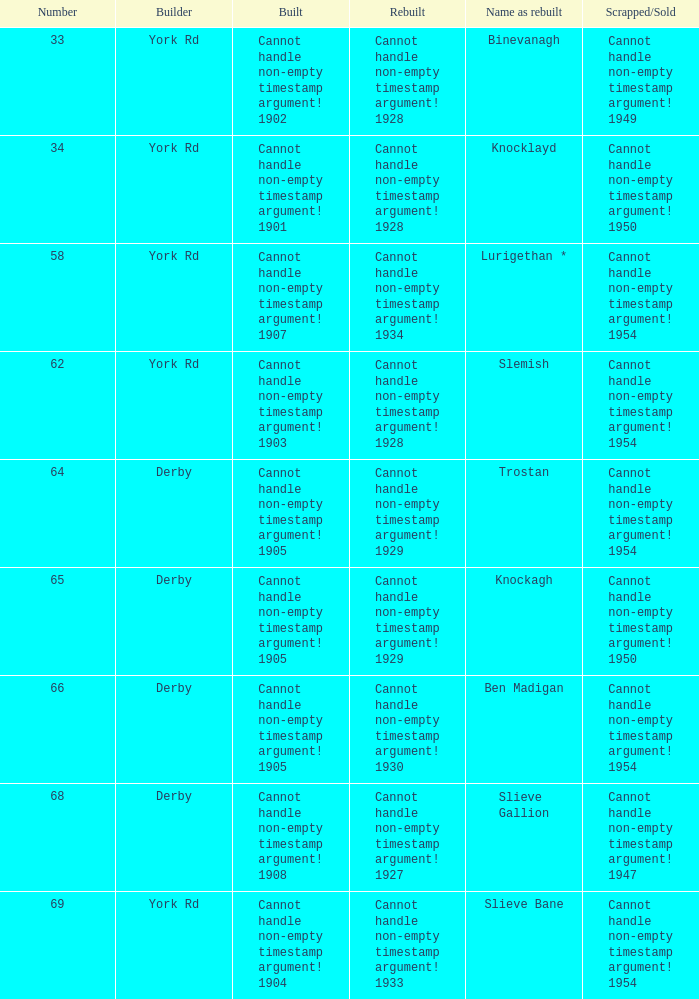Which disassembled or sold entity has a constructor from derby and a name upon reassembly as ben madigan? Cannot handle non-empty timestamp argument! 1954. 